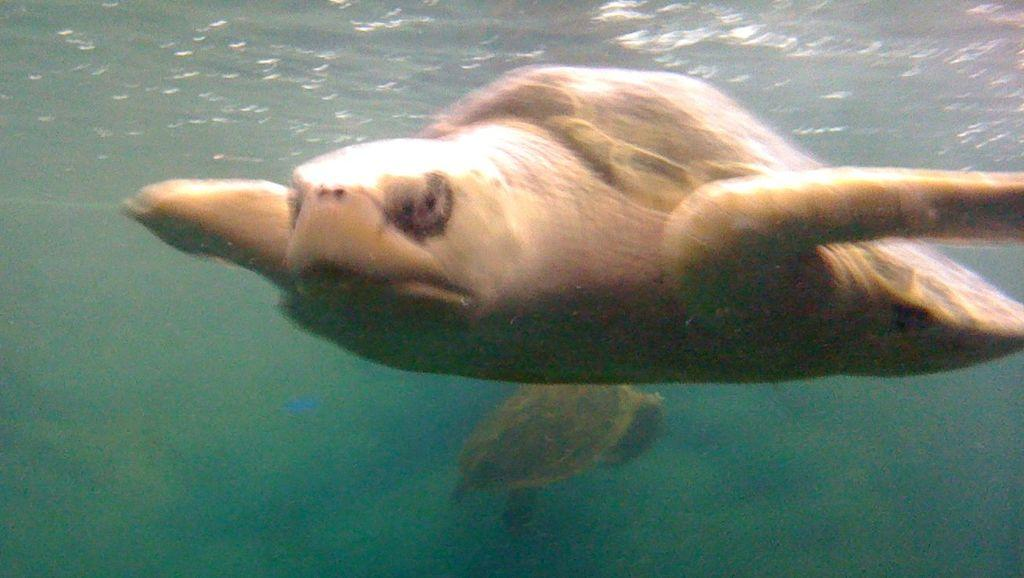What type of animals are in the image? There are turtles in the image. Where are the turtles located? The turtles are in the water. What type of sack is being used to carry the turtles in the image? There is no sack present in the image, as the turtles are in the water. What type of education do the turtles have in the image? The image does not provide any information about the turtles' education. 